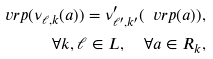Convert formula to latex. <formula><loc_0><loc_0><loc_500><loc_500>\ v r p ( \nu _ { \ell , k } ( a ) ) = \nu ^ { \prime } _ { \ell ^ { \prime } , k ^ { \prime } } ( \ v r p ( a ) ) , \\ \quad \forall k , \ell \in L , \quad \forall a \in R _ { k } ,</formula> 